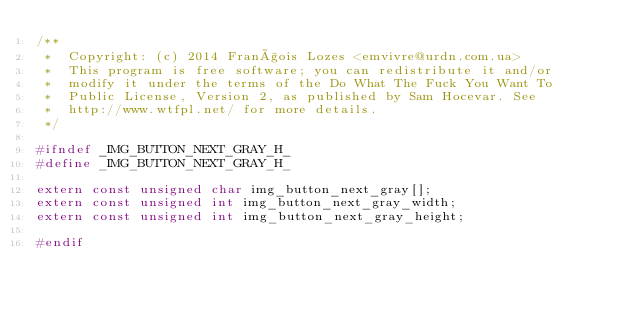<code> <loc_0><loc_0><loc_500><loc_500><_C_>/**
 *  Copyright: (c) 2014 François Lozes <emvivre@urdn.com.ua>
 *  This program is free software; you can redistribute it and/or
 *  modify it under the terms of the Do What The Fuck You Want To
 *  Public License, Version 2, as published by Sam Hocevar. See
 *  http://www.wtfpl.net/ for more details.
 */

#ifndef _IMG_BUTTON_NEXT_GRAY_H_
#define _IMG_BUTTON_NEXT_GRAY_H_

extern const unsigned char img_button_next_gray[];
extern const unsigned int img_button_next_gray_width;
extern const unsigned int img_button_next_gray_height;

#endif
</code> 